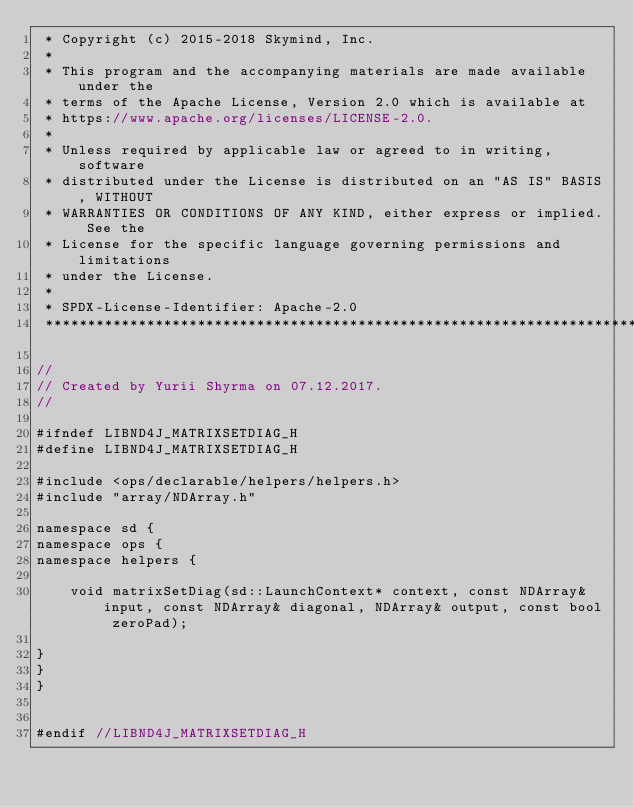<code> <loc_0><loc_0><loc_500><loc_500><_C_> * Copyright (c) 2015-2018 Skymind, Inc.
 *
 * This program and the accompanying materials are made available under the
 * terms of the Apache License, Version 2.0 which is available at
 * https://www.apache.org/licenses/LICENSE-2.0.
 *
 * Unless required by applicable law or agreed to in writing, software
 * distributed under the License is distributed on an "AS IS" BASIS, WITHOUT
 * WARRANTIES OR CONDITIONS OF ANY KIND, either express or implied. See the
 * License for the specific language governing permissions and limitations
 * under the License.
 *
 * SPDX-License-Identifier: Apache-2.0
 ******************************************************************************/

//
// Created by Yurii Shyrma on 07.12.2017.
//

#ifndef LIBND4J_MATRIXSETDIAG_H
#define LIBND4J_MATRIXSETDIAG_H

#include <ops/declarable/helpers/helpers.h>
#include "array/NDArray.h"

namespace sd {
namespace ops {
namespace helpers {

    void matrixSetDiag(sd::LaunchContext* context, const NDArray& input, const NDArray& diagonal, NDArray& output, const bool zeroPad);

}
}
}


#endif //LIBND4J_MATRIXSETDIAG_H
</code> 